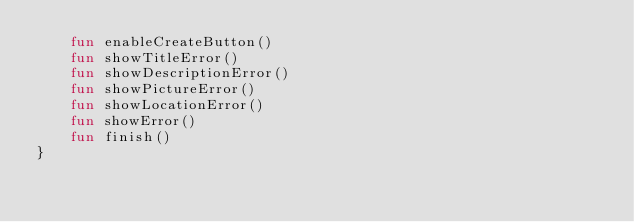<code> <loc_0><loc_0><loc_500><loc_500><_Kotlin_>    fun enableCreateButton()
    fun showTitleError()
    fun showDescriptionError()
    fun showPictureError()
    fun showLocationError()
    fun showError()
    fun finish()
}</code> 